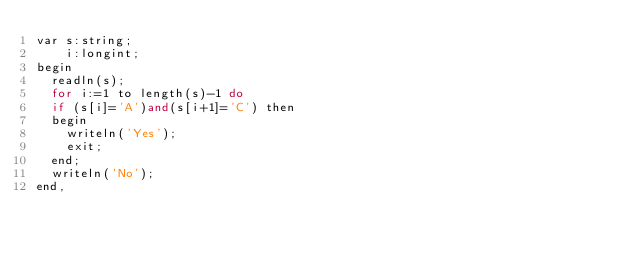Convert code to text. <code><loc_0><loc_0><loc_500><loc_500><_C++_>var s:string;
    i:longint;
begin
  readln(s);
  for i:=1 to length(s)-1 do
  if (s[i]='A')and(s[i+1]='C') then
  begin
    writeln('Yes');
    exit;
  end;
  writeln('No');
end,</code> 